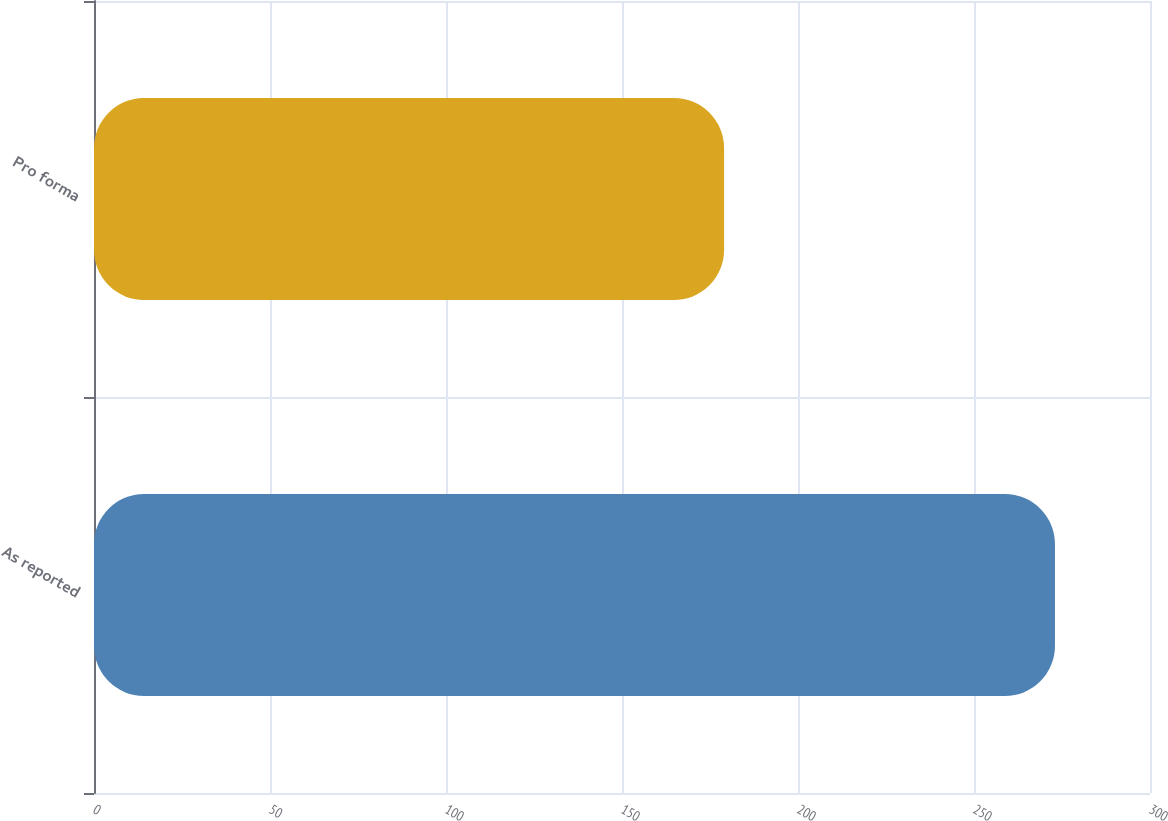Convert chart. <chart><loc_0><loc_0><loc_500><loc_500><bar_chart><fcel>As reported<fcel>Pro forma<nl><fcel>273<fcel>179<nl></chart> 